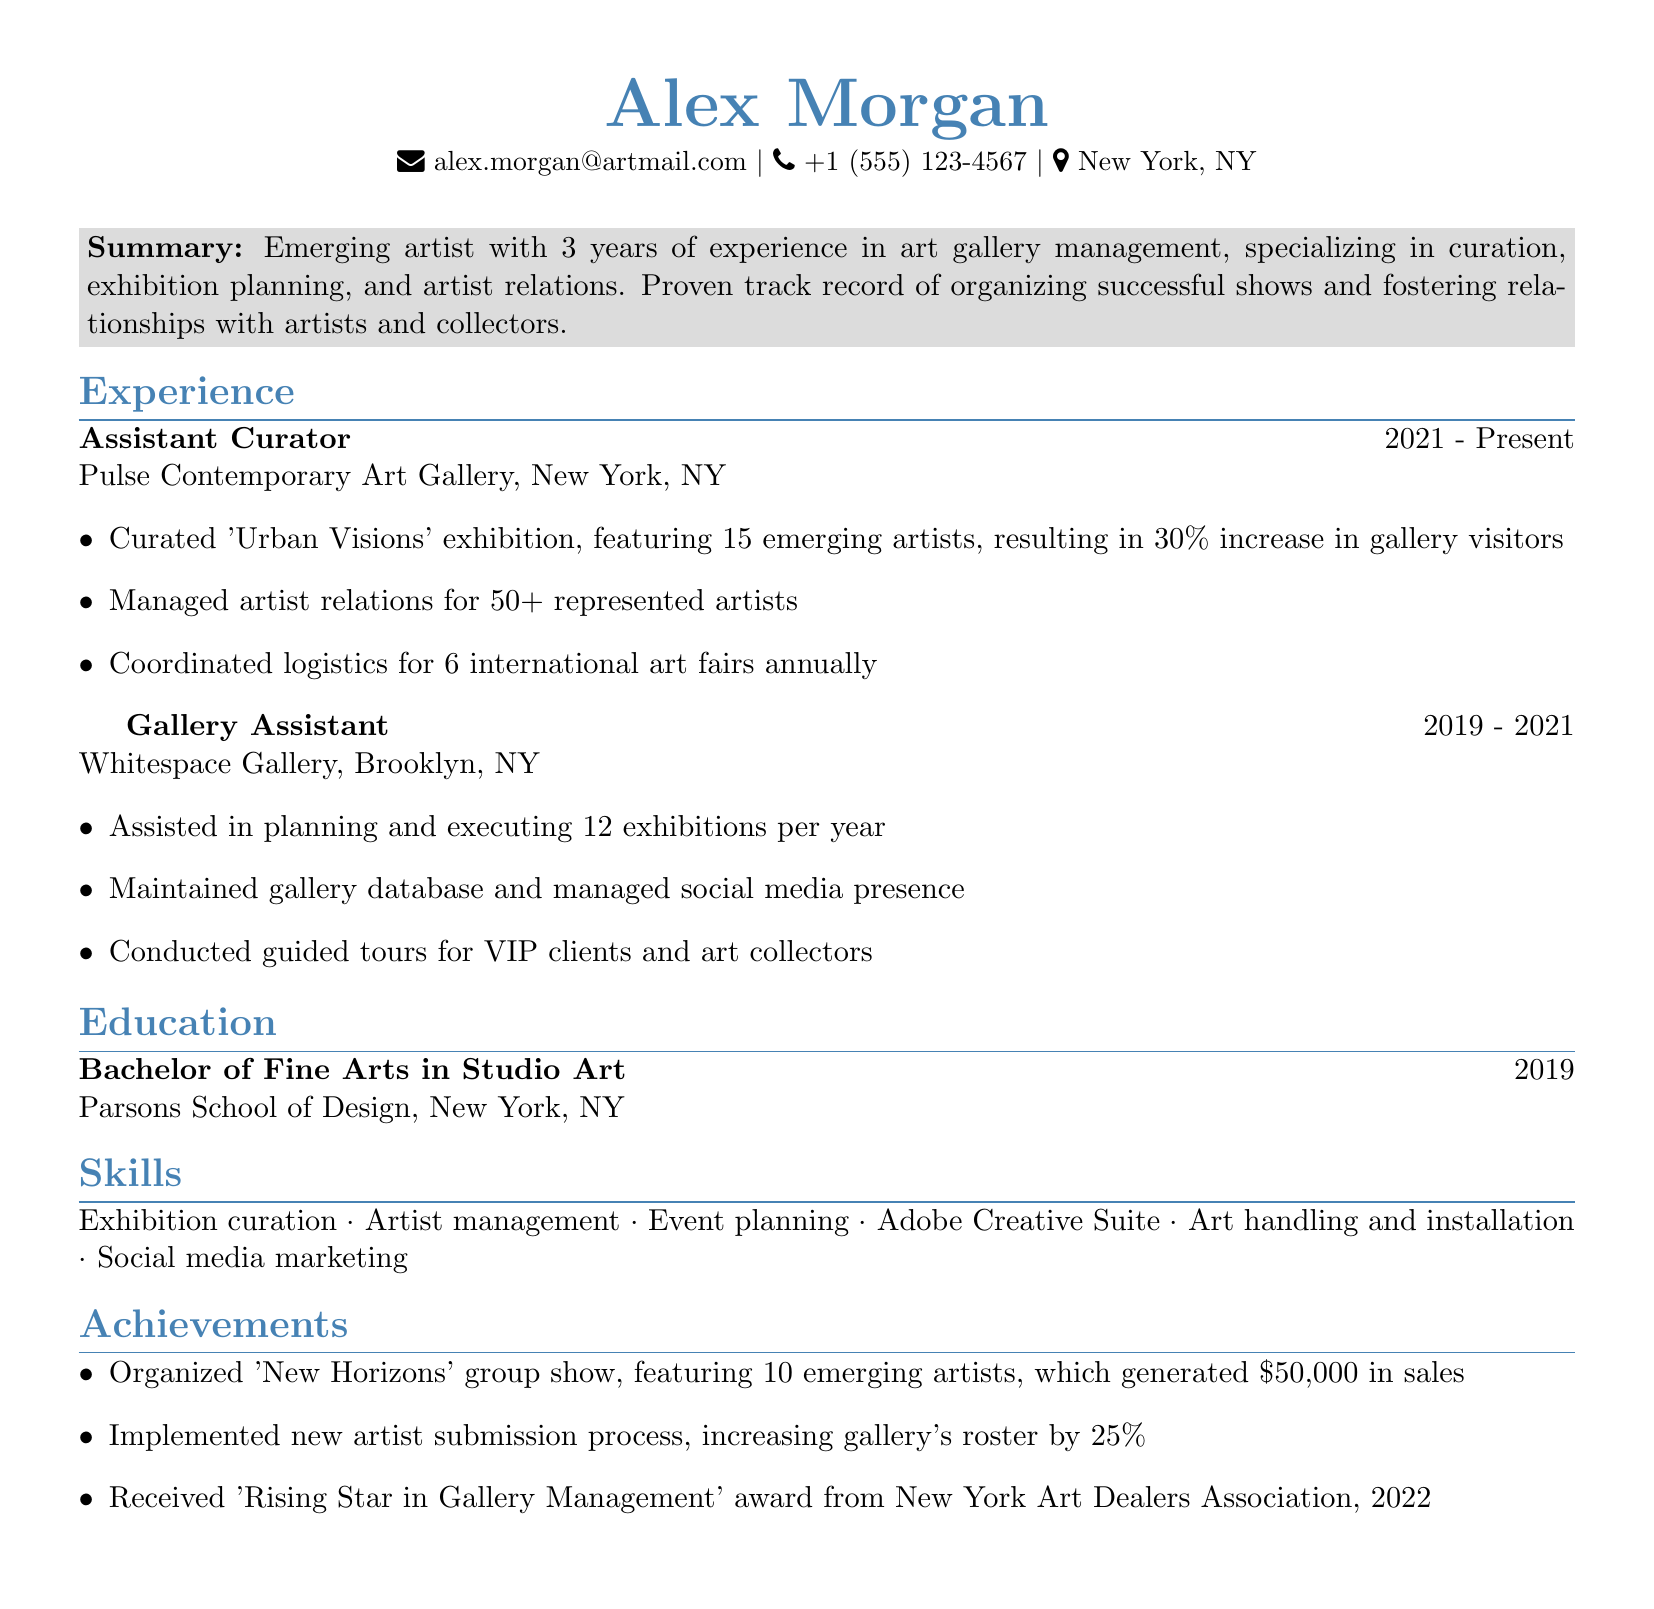what is the name of the artist? The name of the artist is prominently listed at the top of the document.
Answer: Alex Morgan what is the email address of Alex Morgan? The email address for Alex Morgan is shown in the contact information section.
Answer: alex.morgan@artmail.com when did Alex graduate? The graduation year is stated in the education section of the document.
Answer: 2019 how many exhibitions did Alex assist in planning at Whitespace Gallery? The number of exhibitions is detailed in the responsibilities for the Gallery Assistant role.
Answer: 12 what award did Alex receive in 2022? The specific award received by Alex is mentioned in the achievements section.
Answer: Rising Star in Gallery Management what was the total revenue generated by the 'New Horizons' group show? The total revenue from the exhibition is noted in the achievements section of the document.
Answer: $50,000 how many emerging artists were featured in the 'Urban Visions' exhibition? The number of artists featured is indicated in the responsibilities of the Assistant Curator role.
Answer: 15 who did Alex manage artist relations for at Pulse Contemporary Art Gallery? The number of artists managed is mentioned in the responsibilities of the Assistant Curator role.
Answer: 50+ how long has Alex been working at Pulse Contemporary Art Gallery? The duration of the employment is specified in the experience section.
Answer: 2 years what degree did Alex earn? The degree awarded is listed in the education section of the document.
Answer: Bachelor of Fine Arts 